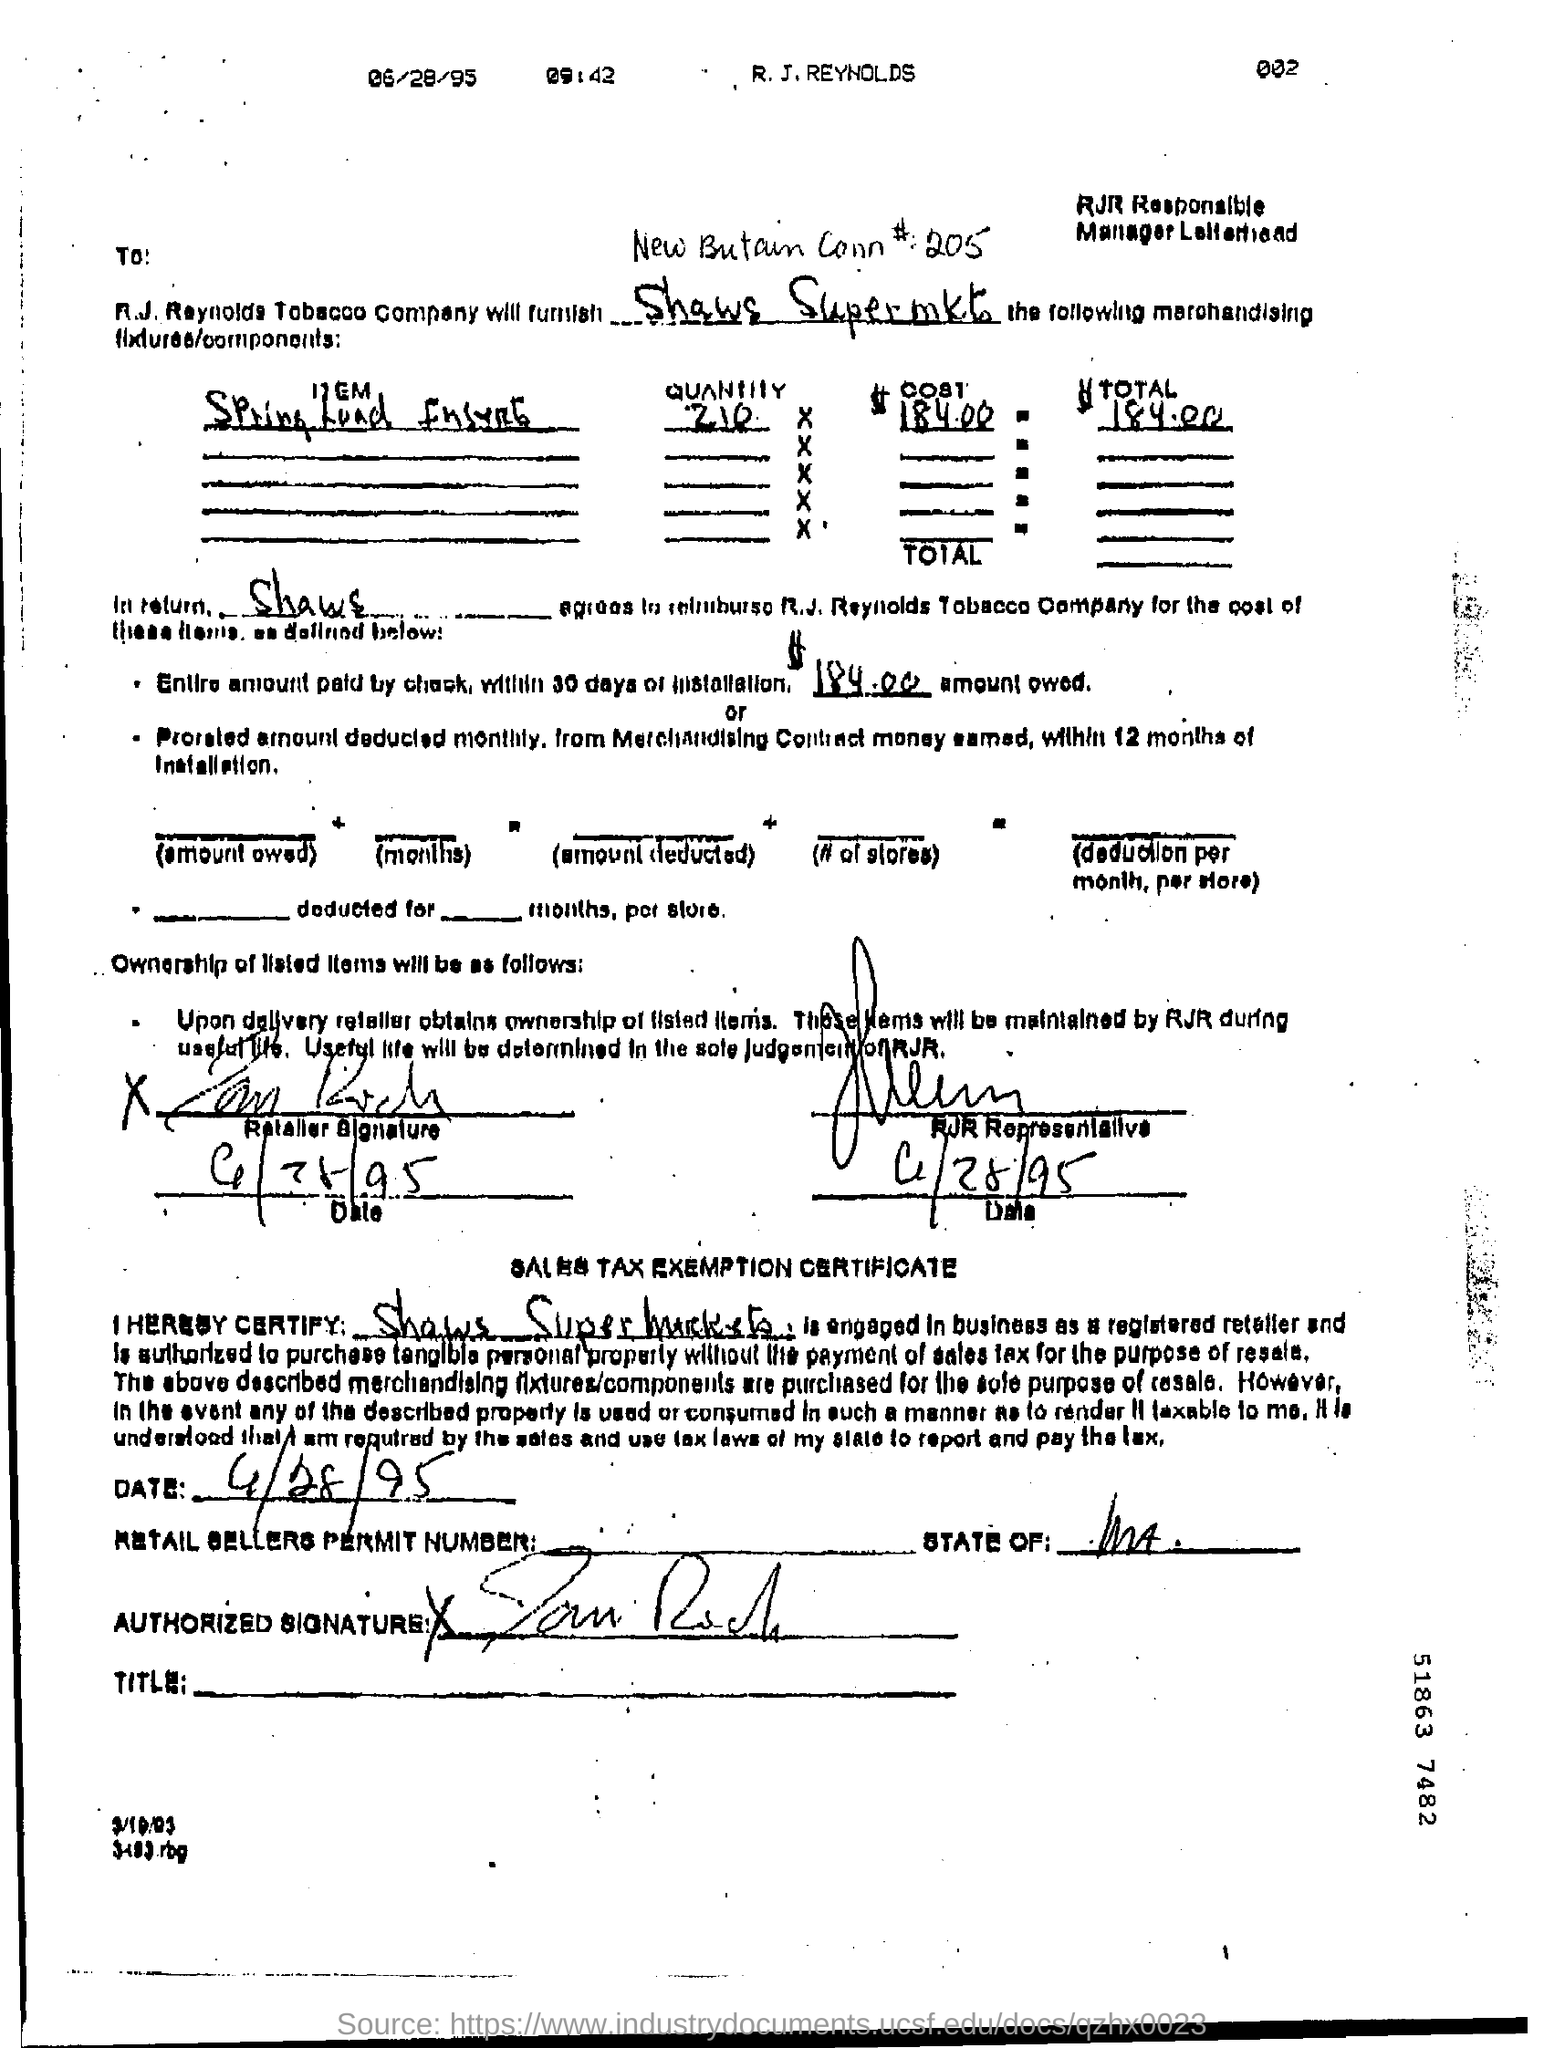What is the date printed at the top of the document in small letters?
Make the answer very short. 06/28/95. What is the time specified in small letters at the top of the document?
Offer a very short reply. 09:42. On what date the retailer signed the document?
Keep it short and to the point. 6/28/95. On which date the RJR Representative  signed?
Provide a succinct answer. 6/28/95. Under "Sales tax exemption certificate" which supermarket's name is mentioned?
Offer a very short reply. Shaws Supermarkets. What is date in sales tax exemption certificate ?
Give a very brief answer. 4/28/95. 